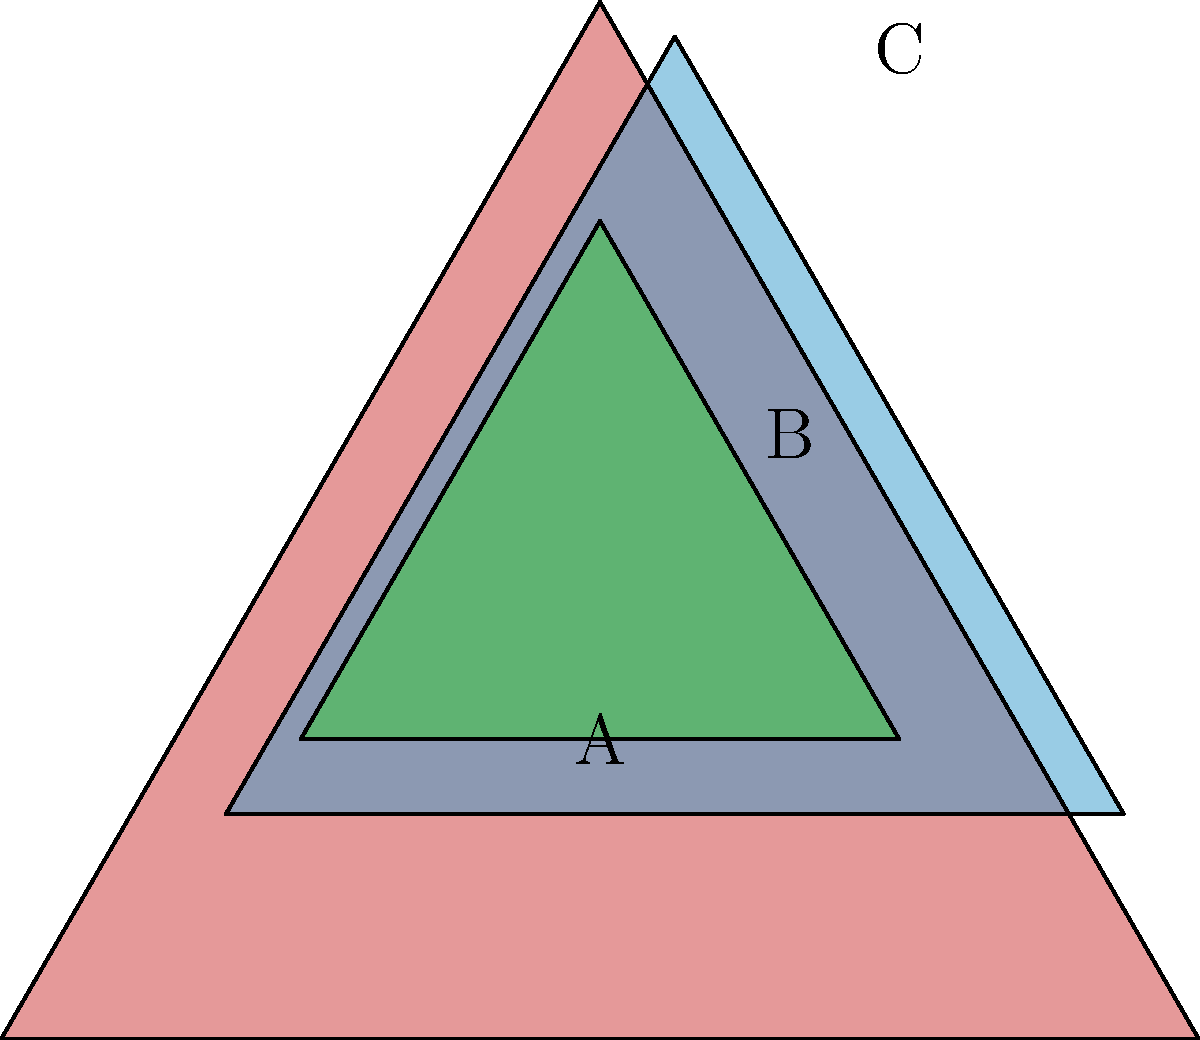In the given composition of overlapping triangles, triangle B is created by scaling and translating triangle A, and triangle C is created by scaling and translating triangle B. If the area of triangle A is 16 square units, what is the combined area of the non-overlapping portions of all three triangles? Let's approach this step-by-step:

1) First, we need to determine the scaling factors:
   - Triangle B is 0.75 times the size of triangle A
   - Triangle C is 0.5 times the size of triangle B, or 0.375 times the size of triangle A

2) Given that the area of triangle A is 16 square units, we can calculate the areas of B and C:
   - Area of B = $16 * 0.75^2 = 16 * 0.5625 = 9$ square units
   - Area of C = $16 * 0.375^2 = 16 * 0.140625 = 2.25$ square units

3) Now, we need to consider the overlapping portions:
   - The visible (non-overlapping) part of A is its full area minus the areas of B and C
   - The visible part of B is its full area minus the area of C
   - The visible part of C is its full area (as it's on top)

4) Let's calculate:
   - Visible area of A = $16 - 9 - 2.25 = 4.75$ square units
   - Visible area of B = $9 - 2.25 = 6.75$ square units
   - Visible area of C = $2.25$ square units

5) The total non-overlapping area is the sum of these visible areas:
   $4.75 + 6.75 + 2.25 = 13.75$ square units

Therefore, the combined area of the non-overlapping portions is 13.75 square units.
Answer: 13.75 square units 